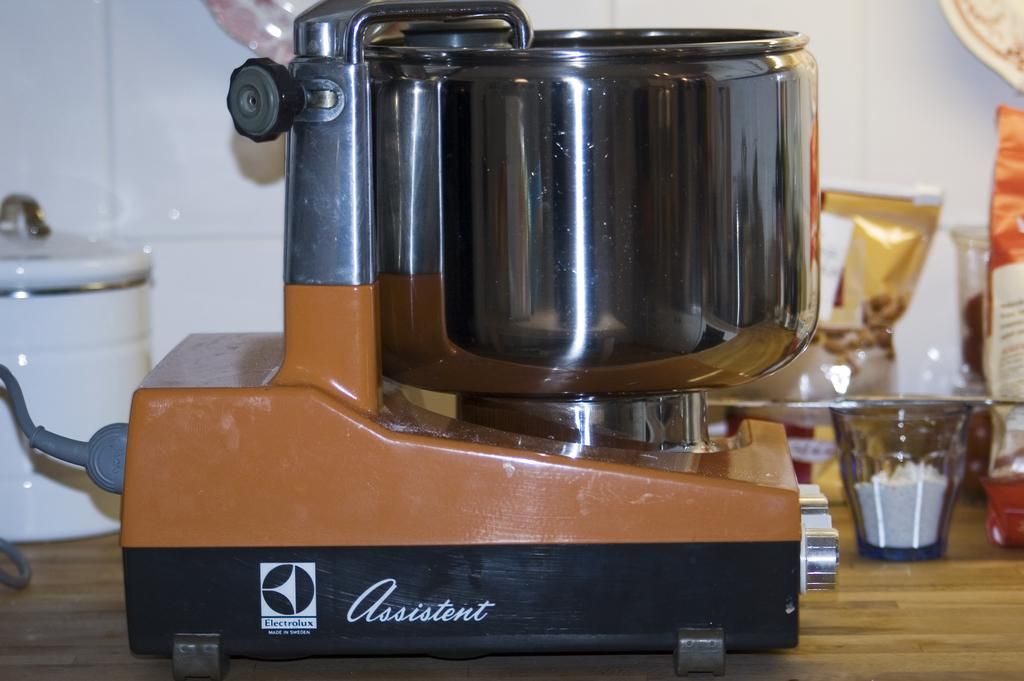<image>
Present a compact description of the photo's key features. An old cooking device called the Assistent is shown on a wooden counter. 